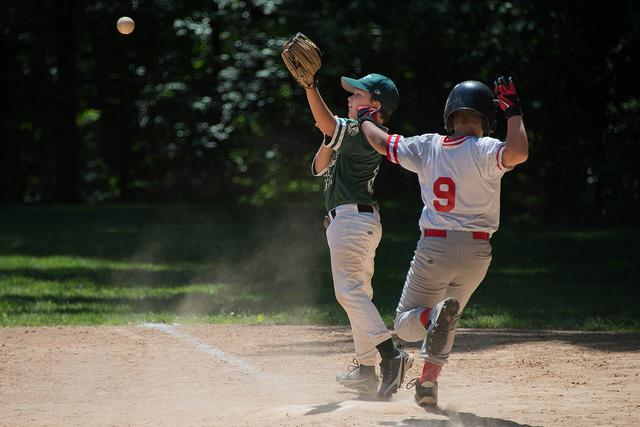What is his team number?
Be succinct. 9. What object is flying in this image?
Concise answer only. Baseball. How many teams are represented in the photo?
Concise answer only. 2. What is the man getting ready to throw?
Short answer required. Baseball. Is this a pro game?
Quick response, please. No. IS this person playing baseball?
Short answer required. Yes. What color is his hat?
Write a very short answer. Green. What is the red number?
Keep it brief. 9. What is the boy holding?
Keep it brief. Glove. What color is the ball?
Short answer required. White. What is being caught?
Answer briefly. Baseball. Has the batter made it to first base?
Quick response, please. Yes. What are the men doing?
Be succinct. Playing baseball. 